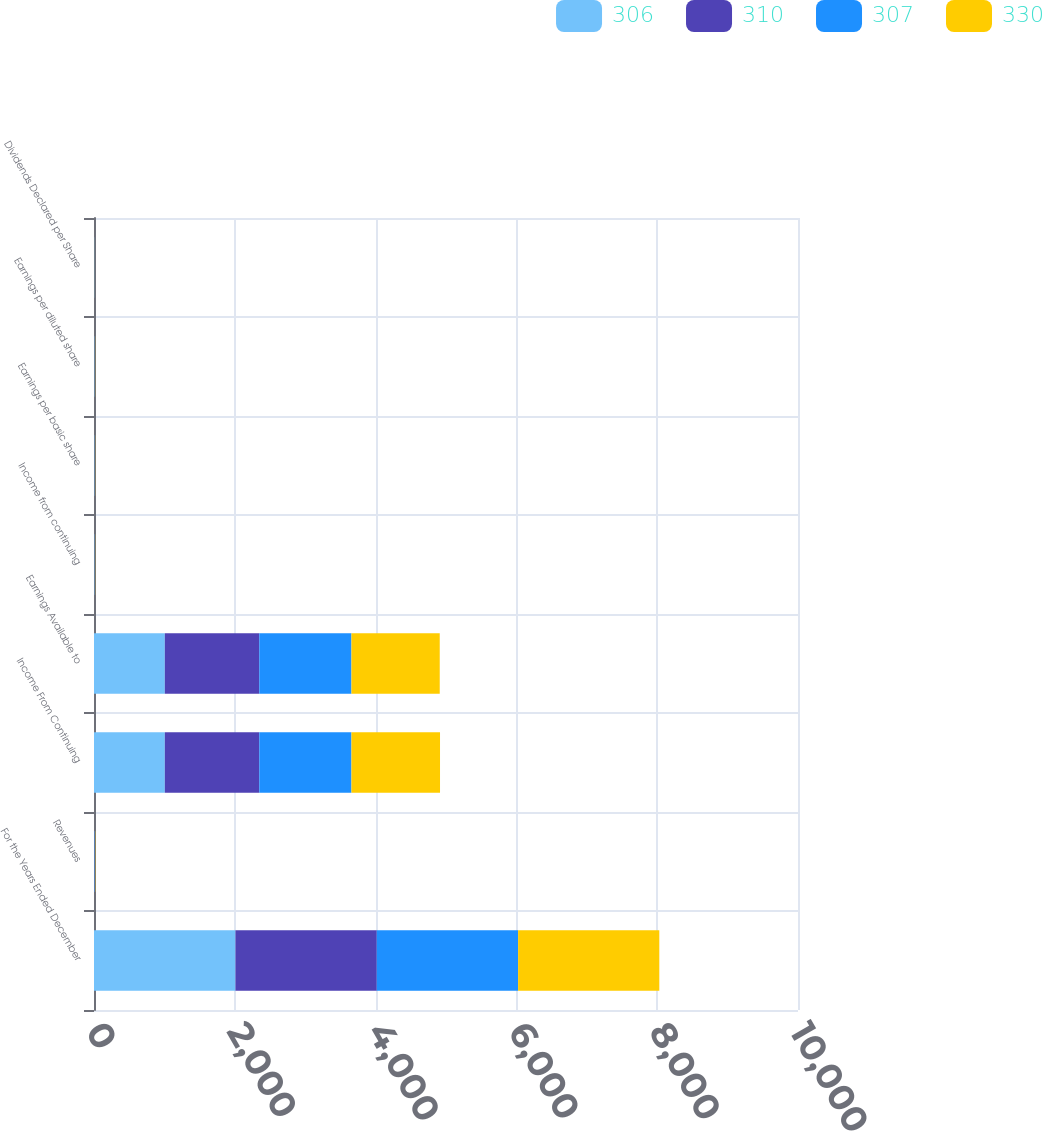Convert chart. <chart><loc_0><loc_0><loc_500><loc_500><stacked_bar_chart><ecel><fcel>For the Years Ended December<fcel>Revenues<fcel>Income From Continuing<fcel>Earnings Available to<fcel>Income from continuing<fcel>Earnings per basic share<fcel>Earnings per diluted share<fcel>Dividends Declared per Share<nl><fcel>306<fcel>2009<fcel>4.395<fcel>1006<fcel>1006<fcel>3.31<fcel>3.31<fcel>3.29<fcel>2.2<nl><fcel>310<fcel>2008<fcel>4.395<fcel>1342<fcel>1342<fcel>4.41<fcel>4.41<fcel>4.38<fcel>2.2<nl><fcel>307<fcel>2007<fcel>4.395<fcel>1309<fcel>1309<fcel>4.27<fcel>4.27<fcel>4.22<fcel>2.05<nl><fcel>330<fcel>2006<fcel>4.395<fcel>1258<fcel>1254<fcel>3.85<fcel>3.84<fcel>3.81<fcel>1.85<nl></chart> 